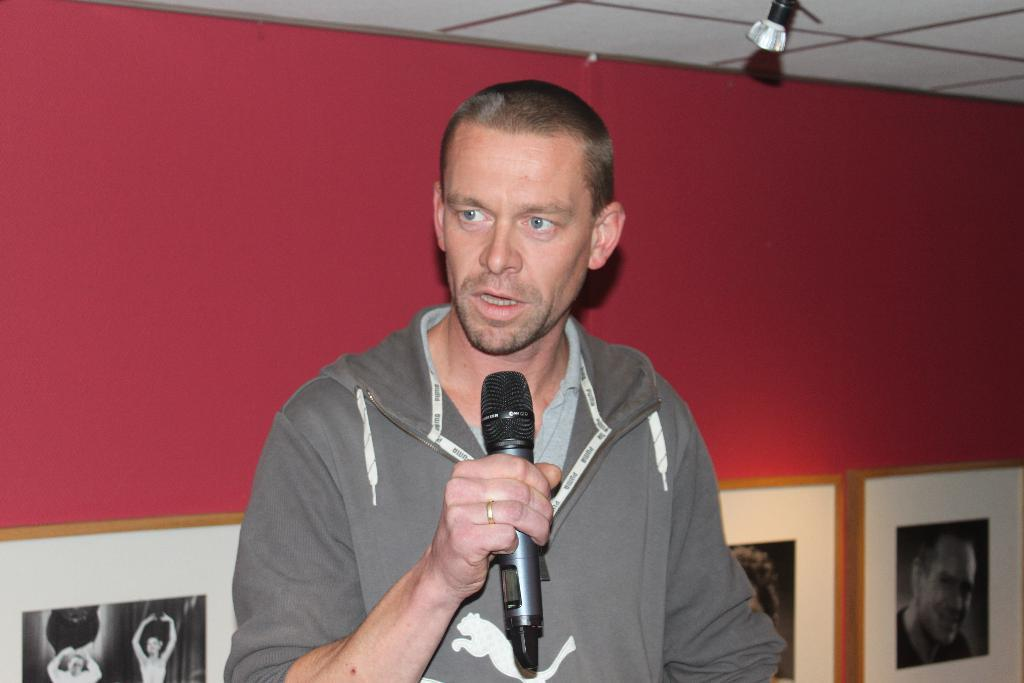What is the main subject of the image? There is a man in the image. What is the man doing in the image? The man is standing and holding a mic in his hand. What can be seen in the background of the image? There is a wall with picture frames in the background of the image. What is visible at the top of the image? The ceiling is visible at the top of the image. What sign is the man holding in the image? There is no sign present in the image; the man is holding a mic. What chance does the man have of becoming an expert in the field of mic holding? The image does not provide any information about the man's chances of becoming an expert in mic holding or any other field. 